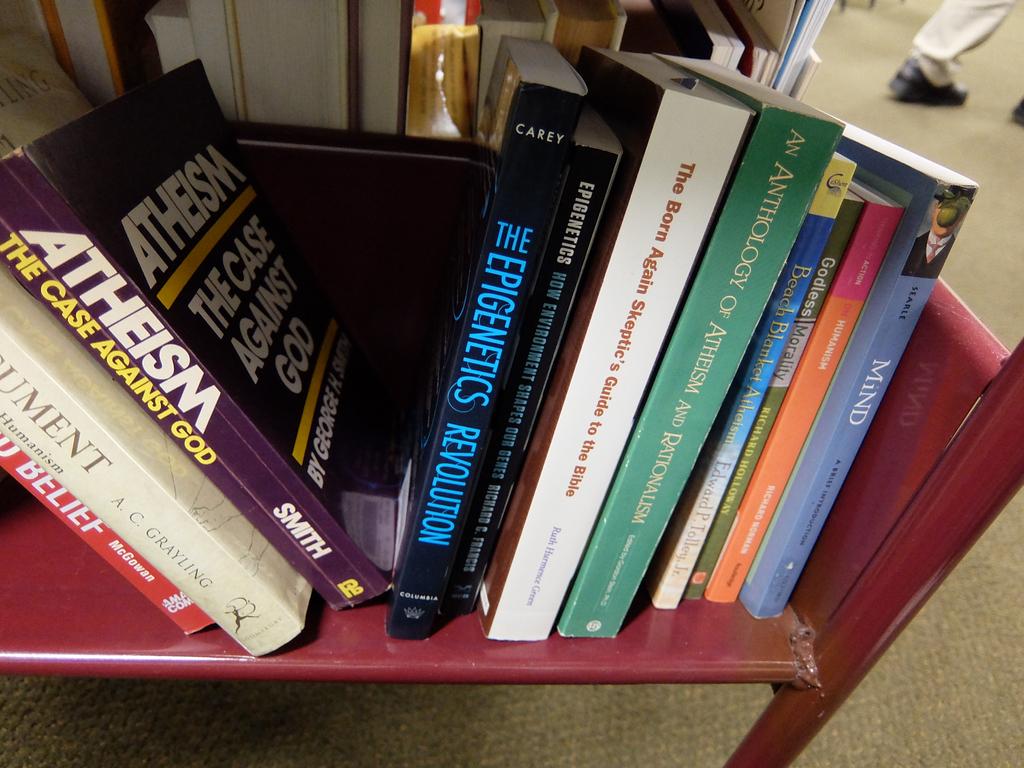What is the subtext on the purple atheism book?
Make the answer very short. The case against god. 